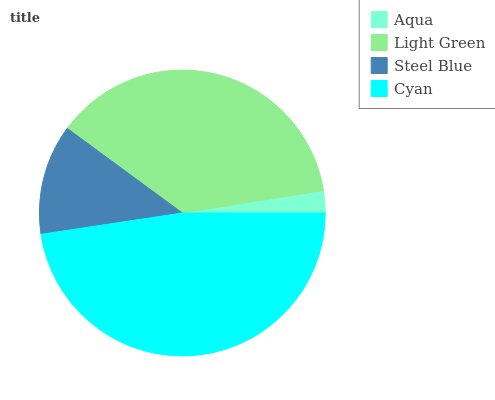Is Aqua the minimum?
Answer yes or no. Yes. Is Cyan the maximum?
Answer yes or no. Yes. Is Light Green the minimum?
Answer yes or no. No. Is Light Green the maximum?
Answer yes or no. No. Is Light Green greater than Aqua?
Answer yes or no. Yes. Is Aqua less than Light Green?
Answer yes or no. Yes. Is Aqua greater than Light Green?
Answer yes or no. No. Is Light Green less than Aqua?
Answer yes or no. No. Is Light Green the high median?
Answer yes or no. Yes. Is Steel Blue the low median?
Answer yes or no. Yes. Is Steel Blue the high median?
Answer yes or no. No. Is Cyan the low median?
Answer yes or no. No. 